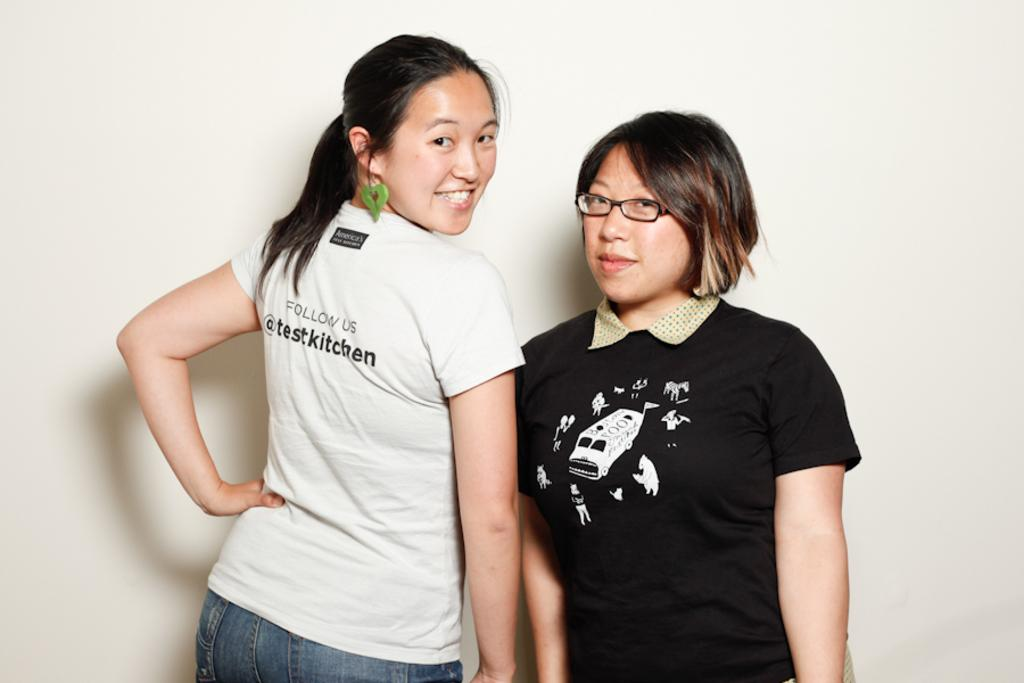How many people are the people can be seen in the image? There are a few people in the image. Can you describe the background of the image? The background of the image is visible. What flavor of root can be tasted in the image? There is no root or flavor mentioned in the image; it only shows a few people and a visible background. 